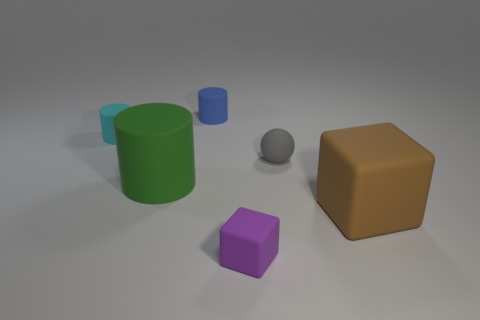Does the big cube have the same color as the small rubber block?
Offer a very short reply. No. How many green objects are either cylinders or tiny matte objects?
Offer a terse response. 1. Is the number of small cyan rubber objects in front of the large block less than the number of large rubber things?
Your answer should be very brief. Yes. How many small blue things are in front of the large object left of the small rubber block?
Your answer should be compact. 0. How many other things are there of the same size as the purple matte cube?
Provide a short and direct response. 3. How many things are green cylinders or rubber things right of the purple matte thing?
Keep it short and to the point. 3. Are there fewer blue cylinders than small matte cylinders?
Make the answer very short. Yes. There is a tiny thing in front of the cylinder in front of the tiny gray rubber sphere; what is its color?
Your response must be concise. Purple. What material is the purple object that is the same shape as the large brown thing?
Provide a short and direct response. Rubber. How many matte objects are either small cyan cylinders or tiny gray things?
Ensure brevity in your answer.  2. 